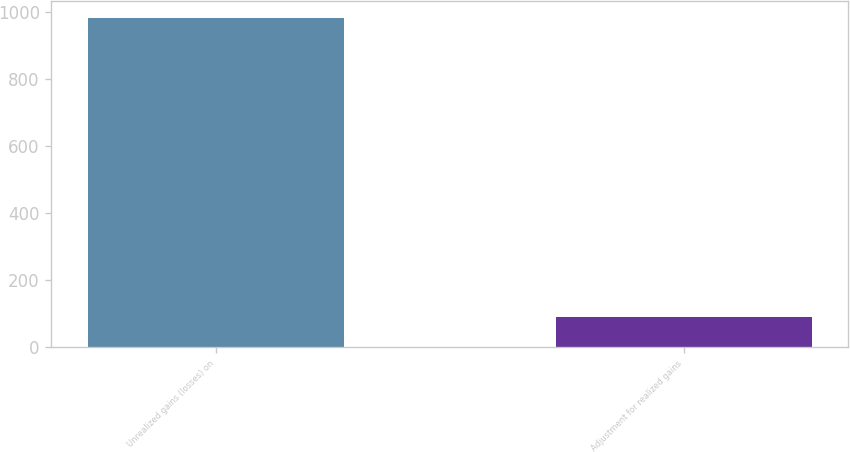Convert chart. <chart><loc_0><loc_0><loc_500><loc_500><bar_chart><fcel>Unrealized gains (losses) on<fcel>Adjustment for realized gains<nl><fcel>984.3<fcel>88.9<nl></chart> 